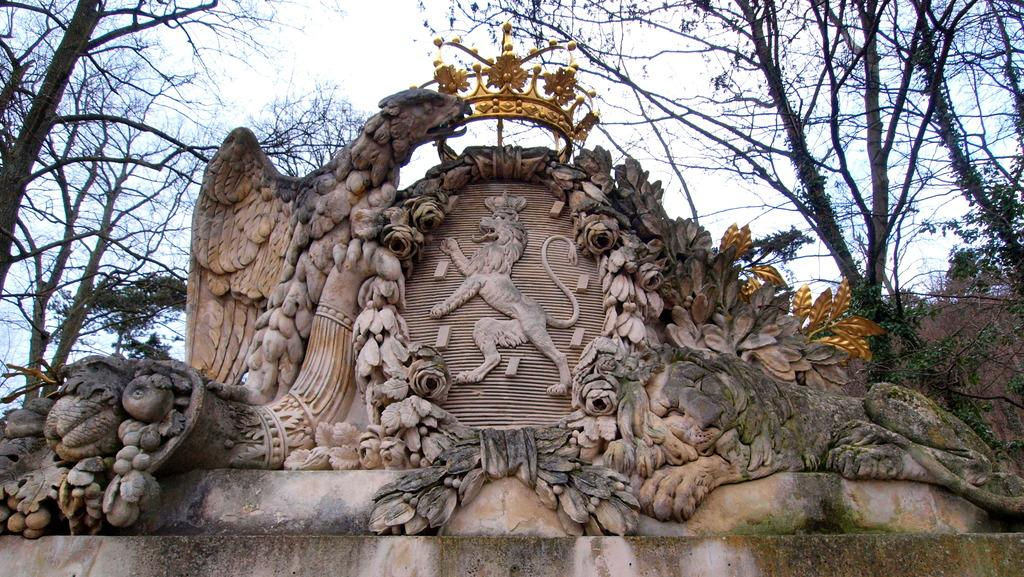What type of objects are featured in the image with craft designs? There are stones with craft designs in the image. What specific designs can be seen on the stones? The craft designs include flowers and a lion statue. What is placed on top of the stones? There is a golden color crown on top of the stones. What can be seen in the background of the image? Dry trees are visible in the background of the image. What type of flag is flying in the image? There is no flag present in the image. How does the image end, and what is the final scene? The image does not have an ending or a final scene, as it is a still image. 